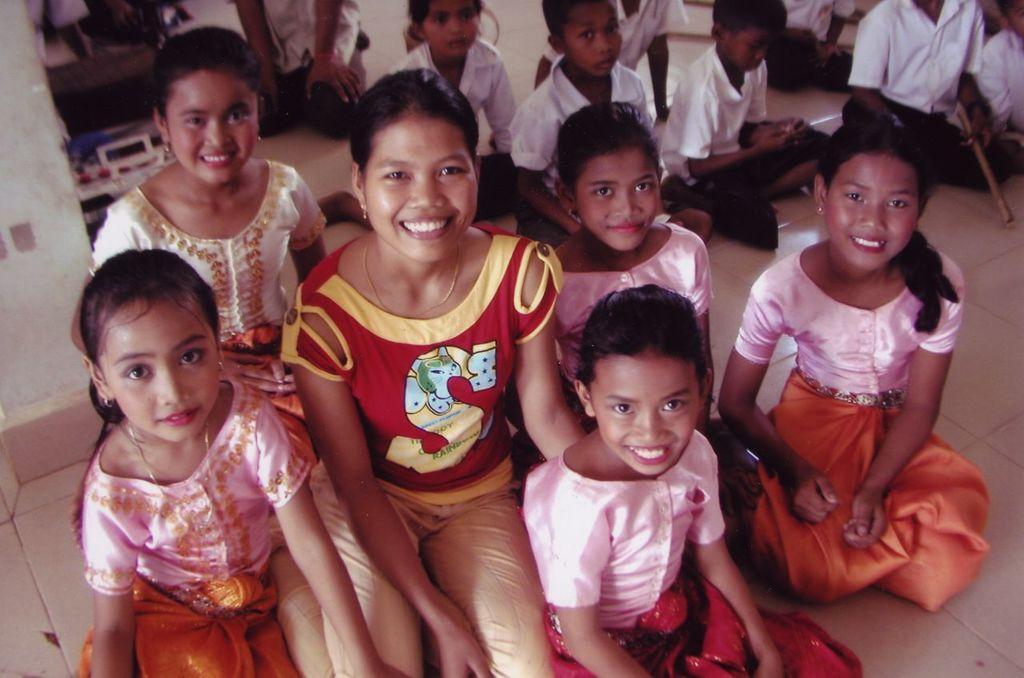In one or two sentences, can you explain what this image depicts? In this picture I can see the children sitting on the floor. I can see a woman sitting on the floor. 